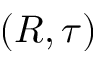<formula> <loc_0><loc_0><loc_500><loc_500>( R , \tau )</formula> 